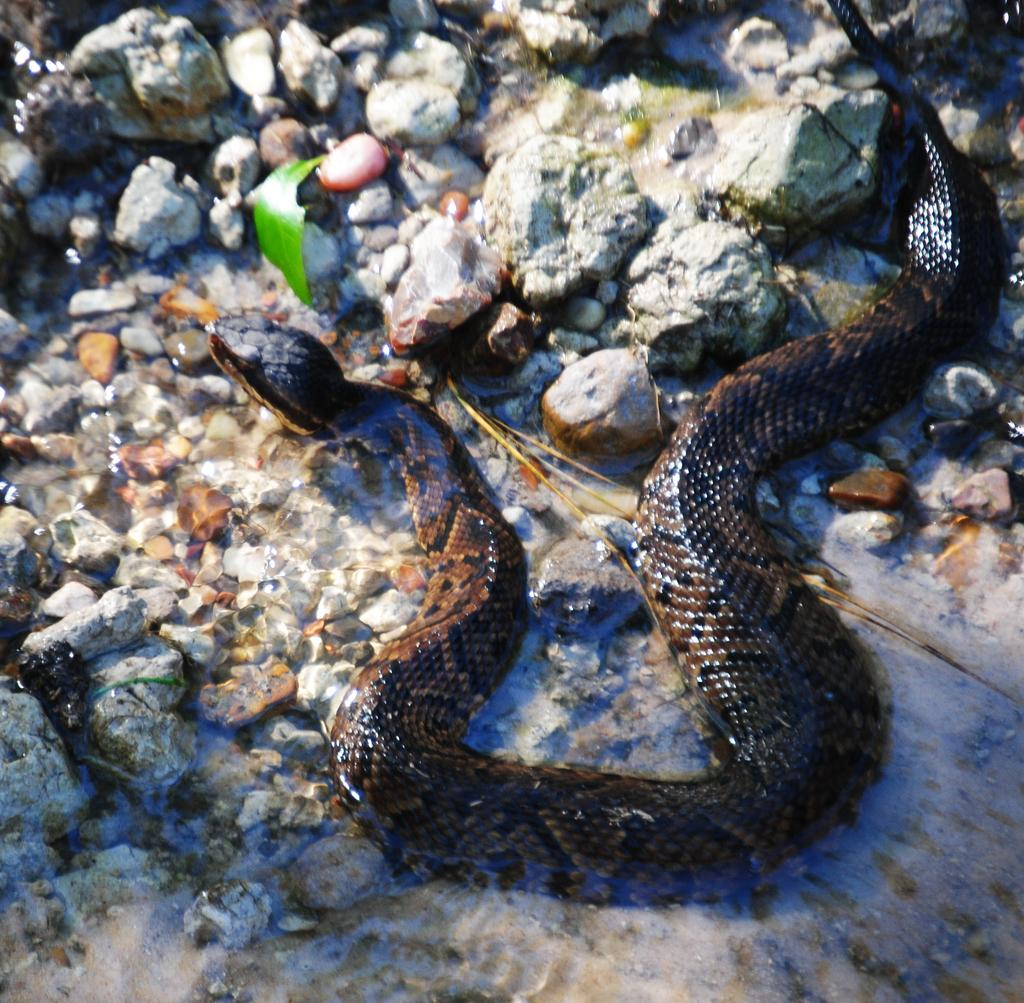What type of animal is present in the image? There is a snake in the image. What else can be seen in the image besides the snake? There are stones in the image. Where is the faucet located in the image? There is no faucet present in the image. 